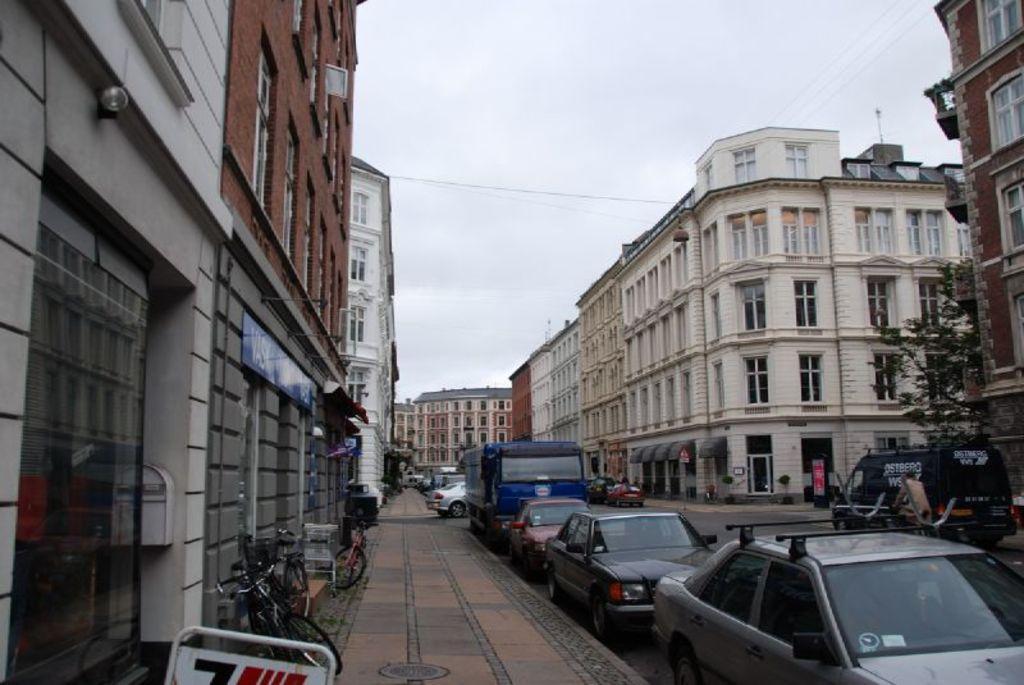Can you describe this image briefly? In this picture I can see vehicles on the road, there are birds, there are buildings, there is a tree, and in the background there is the sky. 